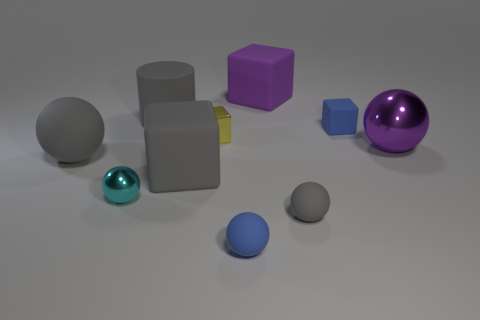Subtract 1 spheres. How many spheres are left? 4 Subtract all brown spheres. Subtract all gray cylinders. How many spheres are left? 5 Subtract all cylinders. How many objects are left? 9 Add 7 large yellow rubber blocks. How many large yellow rubber blocks exist? 7 Subtract 0 green balls. How many objects are left? 10 Subtract all large purple shiny things. Subtract all big rubber blocks. How many objects are left? 7 Add 8 small cubes. How many small cubes are left? 10 